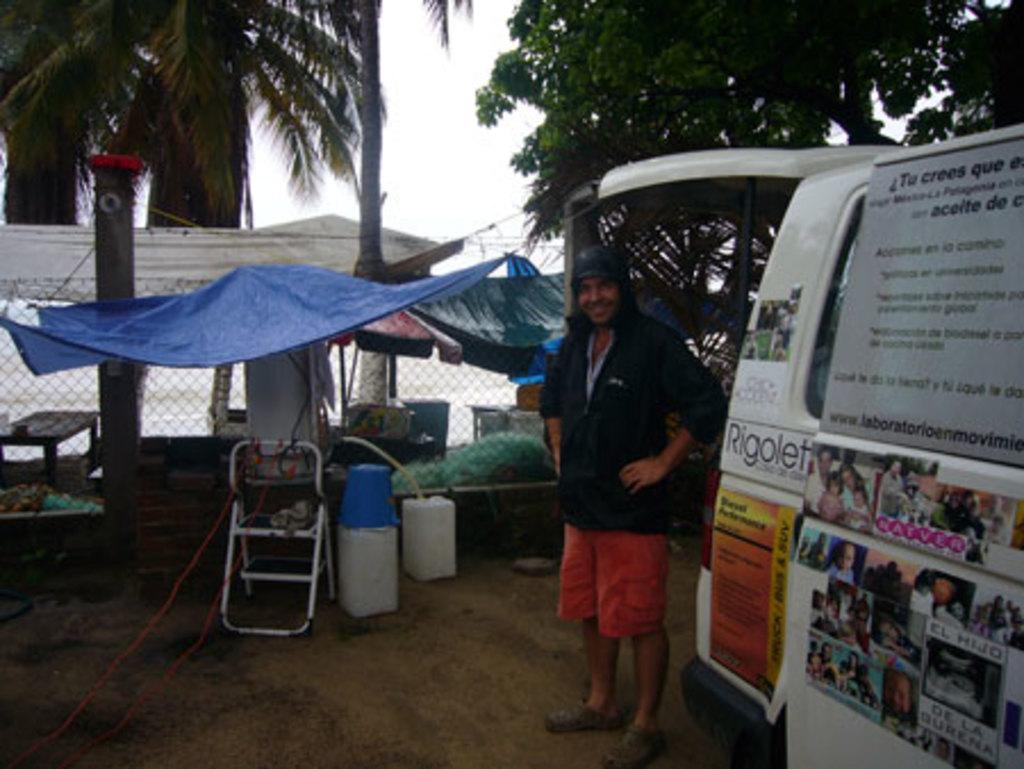Please provide a concise description of this image. In the image we can see there is a person standing and there is a vehicle parked on the ground. There is a blue colour plastic cover tent and there are boxes kept on the ground. Behind there is an iron fencing and there are lot of trees. 